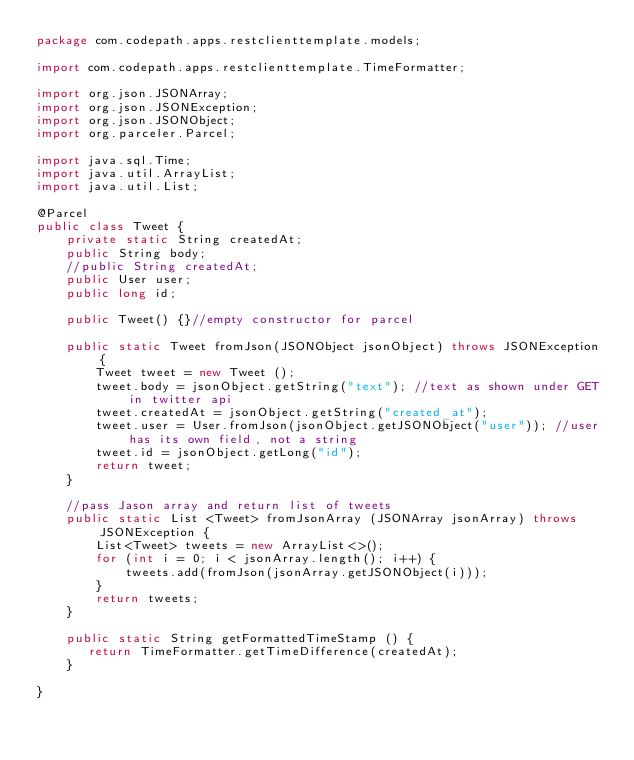Convert code to text. <code><loc_0><loc_0><loc_500><loc_500><_Java_>package com.codepath.apps.restclienttemplate.models;

import com.codepath.apps.restclienttemplate.TimeFormatter;

import org.json.JSONArray;
import org.json.JSONException;
import org.json.JSONObject;
import org.parceler.Parcel;

import java.sql.Time;
import java.util.ArrayList;
import java.util.List;

@Parcel
public class Tweet {
    private static String createdAt;
    public String body;
    //public String createdAt;
    public User user;
    public long id;

    public Tweet() {}//empty constructor for parcel

    public static Tweet fromJson(JSONObject jsonObject) throws JSONException {
        Tweet tweet = new Tweet ();
        tweet.body = jsonObject.getString("text"); //text as shown under GET in twitter api
        tweet.createdAt = jsonObject.getString("created_at");
        tweet.user = User.fromJson(jsonObject.getJSONObject("user")); //user has its own field, not a string
        tweet.id = jsonObject.getLong("id");
        return tweet;
    }

    //pass Jason array and return list of tweets
    public static List <Tweet> fromJsonArray (JSONArray jsonArray) throws JSONException {
        List<Tweet> tweets = new ArrayList<>();
        for (int i = 0; i < jsonArray.length(); i++) {
            tweets.add(fromJson(jsonArray.getJSONObject(i)));
        }
        return tweets;
    }

    public static String getFormattedTimeStamp () {
       return TimeFormatter.getTimeDifference(createdAt);
    }

}
</code> 